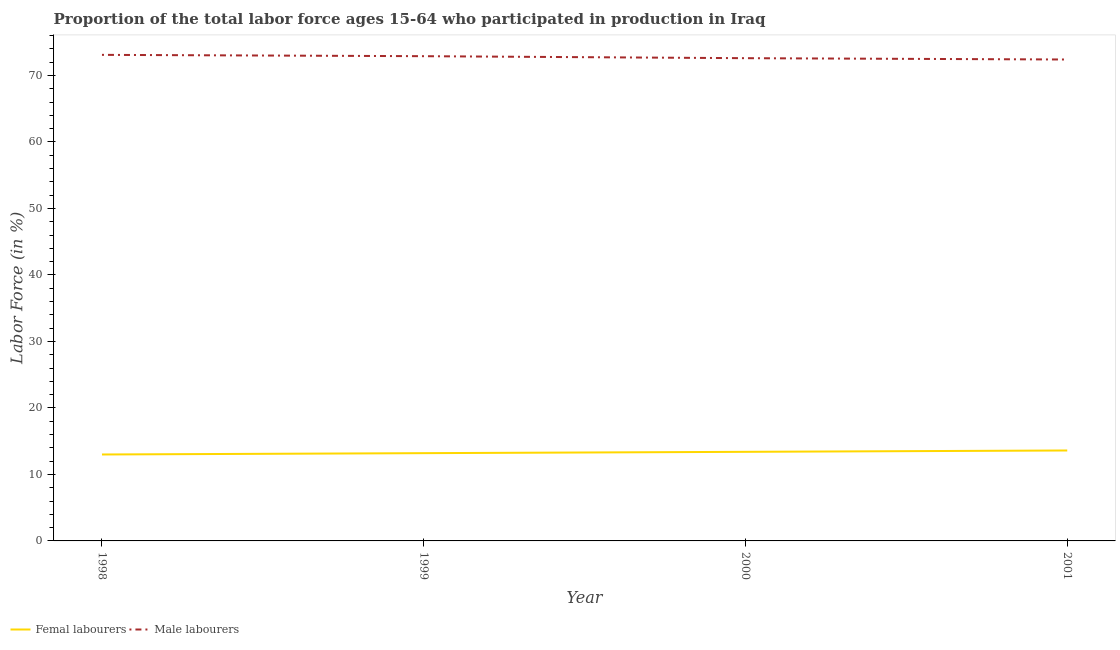Does the line corresponding to percentage of male labour force intersect with the line corresponding to percentage of female labor force?
Make the answer very short. No. What is the percentage of male labour force in 1998?
Provide a succinct answer. 73.1. Across all years, what is the maximum percentage of male labour force?
Give a very brief answer. 73.1. Across all years, what is the minimum percentage of male labour force?
Ensure brevity in your answer.  72.4. In which year was the percentage of female labor force maximum?
Give a very brief answer. 2001. In which year was the percentage of male labour force minimum?
Offer a terse response. 2001. What is the total percentage of female labor force in the graph?
Offer a terse response. 53.2. What is the difference between the percentage of male labour force in 1998 and that in 2001?
Keep it short and to the point. 0.7. What is the difference between the percentage of male labour force in 2000 and the percentage of female labor force in 2001?
Give a very brief answer. 59. What is the average percentage of female labor force per year?
Your answer should be very brief. 13.3. In the year 1999, what is the difference between the percentage of male labour force and percentage of female labor force?
Your response must be concise. 59.7. In how many years, is the percentage of female labor force greater than 72 %?
Keep it short and to the point. 0. What is the ratio of the percentage of female labor force in 1999 to that in 2001?
Your answer should be compact. 0.97. What is the difference between the highest and the second highest percentage of male labour force?
Offer a very short reply. 0.2. What is the difference between the highest and the lowest percentage of female labor force?
Your answer should be compact. 0.6. In how many years, is the percentage of male labour force greater than the average percentage of male labour force taken over all years?
Your answer should be very brief. 2. Is the sum of the percentage of male labour force in 1998 and 2000 greater than the maximum percentage of female labor force across all years?
Give a very brief answer. Yes. Does the percentage of male labour force monotonically increase over the years?
Your answer should be compact. No. Is the percentage of male labour force strictly greater than the percentage of female labor force over the years?
Make the answer very short. Yes. How many lines are there?
Provide a short and direct response. 2. Does the graph contain any zero values?
Give a very brief answer. No. How are the legend labels stacked?
Your answer should be compact. Horizontal. What is the title of the graph?
Provide a short and direct response. Proportion of the total labor force ages 15-64 who participated in production in Iraq. What is the Labor Force (in %) in Male labourers in 1998?
Your answer should be compact. 73.1. What is the Labor Force (in %) of Femal labourers in 1999?
Ensure brevity in your answer.  13.2. What is the Labor Force (in %) in Male labourers in 1999?
Your answer should be compact. 72.9. What is the Labor Force (in %) in Femal labourers in 2000?
Ensure brevity in your answer.  13.4. What is the Labor Force (in %) of Male labourers in 2000?
Your answer should be very brief. 72.6. What is the Labor Force (in %) of Femal labourers in 2001?
Make the answer very short. 13.6. What is the Labor Force (in %) in Male labourers in 2001?
Your answer should be compact. 72.4. Across all years, what is the maximum Labor Force (in %) of Femal labourers?
Provide a short and direct response. 13.6. Across all years, what is the maximum Labor Force (in %) in Male labourers?
Keep it short and to the point. 73.1. Across all years, what is the minimum Labor Force (in %) of Male labourers?
Provide a succinct answer. 72.4. What is the total Labor Force (in %) of Femal labourers in the graph?
Your answer should be compact. 53.2. What is the total Labor Force (in %) in Male labourers in the graph?
Offer a very short reply. 291. What is the difference between the Labor Force (in %) in Femal labourers in 1998 and that in 1999?
Your answer should be compact. -0.2. What is the difference between the Labor Force (in %) of Femal labourers in 1998 and that in 2000?
Provide a short and direct response. -0.4. What is the difference between the Labor Force (in %) of Femal labourers in 1998 and that in 2001?
Give a very brief answer. -0.6. What is the difference between the Labor Force (in %) in Male labourers in 1999 and that in 2001?
Your answer should be very brief. 0.5. What is the difference between the Labor Force (in %) in Femal labourers in 1998 and the Labor Force (in %) in Male labourers in 1999?
Provide a short and direct response. -59.9. What is the difference between the Labor Force (in %) of Femal labourers in 1998 and the Labor Force (in %) of Male labourers in 2000?
Your answer should be very brief. -59.6. What is the difference between the Labor Force (in %) of Femal labourers in 1998 and the Labor Force (in %) of Male labourers in 2001?
Offer a very short reply. -59.4. What is the difference between the Labor Force (in %) in Femal labourers in 1999 and the Labor Force (in %) in Male labourers in 2000?
Your response must be concise. -59.4. What is the difference between the Labor Force (in %) of Femal labourers in 1999 and the Labor Force (in %) of Male labourers in 2001?
Give a very brief answer. -59.2. What is the difference between the Labor Force (in %) in Femal labourers in 2000 and the Labor Force (in %) in Male labourers in 2001?
Provide a short and direct response. -59. What is the average Labor Force (in %) of Male labourers per year?
Provide a succinct answer. 72.75. In the year 1998, what is the difference between the Labor Force (in %) in Femal labourers and Labor Force (in %) in Male labourers?
Make the answer very short. -60.1. In the year 1999, what is the difference between the Labor Force (in %) of Femal labourers and Labor Force (in %) of Male labourers?
Your response must be concise. -59.7. In the year 2000, what is the difference between the Labor Force (in %) in Femal labourers and Labor Force (in %) in Male labourers?
Your answer should be compact. -59.2. In the year 2001, what is the difference between the Labor Force (in %) in Femal labourers and Labor Force (in %) in Male labourers?
Provide a succinct answer. -58.8. What is the ratio of the Labor Force (in %) of Male labourers in 1998 to that in 1999?
Make the answer very short. 1. What is the ratio of the Labor Force (in %) of Femal labourers in 1998 to that in 2000?
Give a very brief answer. 0.97. What is the ratio of the Labor Force (in %) of Male labourers in 1998 to that in 2000?
Make the answer very short. 1.01. What is the ratio of the Labor Force (in %) in Femal labourers in 1998 to that in 2001?
Make the answer very short. 0.96. What is the ratio of the Labor Force (in %) in Male labourers in 1998 to that in 2001?
Offer a very short reply. 1.01. What is the ratio of the Labor Force (in %) of Femal labourers in 1999 to that in 2000?
Give a very brief answer. 0.99. What is the ratio of the Labor Force (in %) in Femal labourers in 1999 to that in 2001?
Keep it short and to the point. 0.97. What is the ratio of the Labor Force (in %) in Male labourers in 1999 to that in 2001?
Make the answer very short. 1.01. What is the ratio of the Labor Force (in %) of Femal labourers in 2000 to that in 2001?
Your answer should be compact. 0.99. What is the difference between the highest and the second highest Labor Force (in %) of Femal labourers?
Your answer should be very brief. 0.2. What is the difference between the highest and the lowest Labor Force (in %) of Male labourers?
Your answer should be compact. 0.7. 